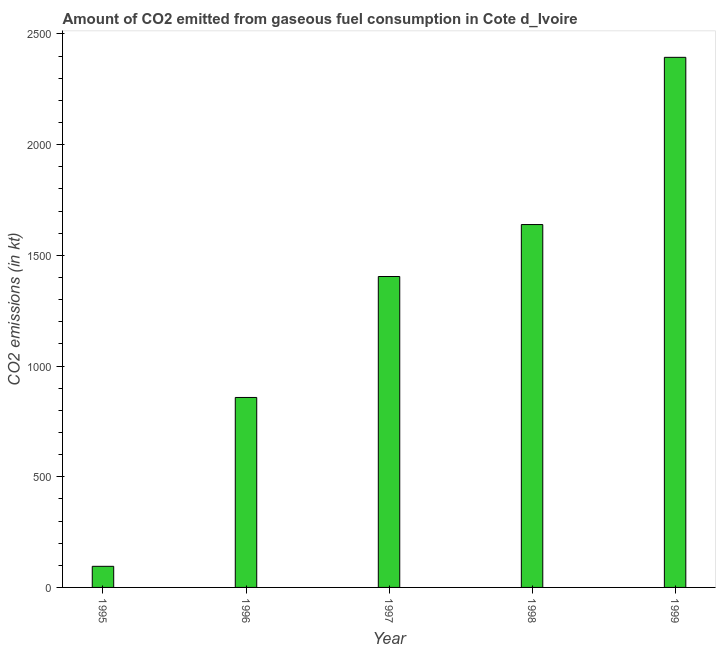Does the graph contain any zero values?
Provide a succinct answer. No. Does the graph contain grids?
Your response must be concise. No. What is the title of the graph?
Offer a very short reply. Amount of CO2 emitted from gaseous fuel consumption in Cote d_Ivoire. What is the label or title of the X-axis?
Offer a very short reply. Year. What is the label or title of the Y-axis?
Your answer should be very brief. CO2 emissions (in kt). What is the co2 emissions from gaseous fuel consumption in 1996?
Make the answer very short. 858.08. Across all years, what is the maximum co2 emissions from gaseous fuel consumption?
Your answer should be very brief. 2394.55. Across all years, what is the minimum co2 emissions from gaseous fuel consumption?
Offer a very short reply. 95.34. What is the sum of the co2 emissions from gaseous fuel consumption?
Provide a succinct answer. 6391.58. What is the difference between the co2 emissions from gaseous fuel consumption in 1998 and 1999?
Provide a succinct answer. -755.4. What is the average co2 emissions from gaseous fuel consumption per year?
Give a very brief answer. 1278.32. What is the median co2 emissions from gaseous fuel consumption?
Give a very brief answer. 1404.46. In how many years, is the co2 emissions from gaseous fuel consumption greater than 1300 kt?
Offer a very short reply. 3. What is the ratio of the co2 emissions from gaseous fuel consumption in 1995 to that in 1998?
Your response must be concise. 0.06. What is the difference between the highest and the second highest co2 emissions from gaseous fuel consumption?
Make the answer very short. 755.4. Is the sum of the co2 emissions from gaseous fuel consumption in 1995 and 1998 greater than the maximum co2 emissions from gaseous fuel consumption across all years?
Your answer should be compact. No. What is the difference between the highest and the lowest co2 emissions from gaseous fuel consumption?
Make the answer very short. 2299.21. In how many years, is the co2 emissions from gaseous fuel consumption greater than the average co2 emissions from gaseous fuel consumption taken over all years?
Give a very brief answer. 3. How many bars are there?
Make the answer very short. 5. Are all the bars in the graph horizontal?
Provide a short and direct response. No. What is the CO2 emissions (in kt) of 1995?
Your answer should be compact. 95.34. What is the CO2 emissions (in kt) of 1996?
Provide a succinct answer. 858.08. What is the CO2 emissions (in kt) of 1997?
Provide a short and direct response. 1404.46. What is the CO2 emissions (in kt) in 1998?
Offer a terse response. 1639.15. What is the CO2 emissions (in kt) in 1999?
Keep it short and to the point. 2394.55. What is the difference between the CO2 emissions (in kt) in 1995 and 1996?
Provide a succinct answer. -762.74. What is the difference between the CO2 emissions (in kt) in 1995 and 1997?
Give a very brief answer. -1309.12. What is the difference between the CO2 emissions (in kt) in 1995 and 1998?
Make the answer very short. -1543.81. What is the difference between the CO2 emissions (in kt) in 1995 and 1999?
Your response must be concise. -2299.21. What is the difference between the CO2 emissions (in kt) in 1996 and 1997?
Provide a short and direct response. -546.38. What is the difference between the CO2 emissions (in kt) in 1996 and 1998?
Your answer should be compact. -781.07. What is the difference between the CO2 emissions (in kt) in 1996 and 1999?
Offer a terse response. -1536.47. What is the difference between the CO2 emissions (in kt) in 1997 and 1998?
Provide a short and direct response. -234.69. What is the difference between the CO2 emissions (in kt) in 1997 and 1999?
Keep it short and to the point. -990.09. What is the difference between the CO2 emissions (in kt) in 1998 and 1999?
Offer a very short reply. -755.4. What is the ratio of the CO2 emissions (in kt) in 1995 to that in 1996?
Offer a very short reply. 0.11. What is the ratio of the CO2 emissions (in kt) in 1995 to that in 1997?
Provide a short and direct response. 0.07. What is the ratio of the CO2 emissions (in kt) in 1995 to that in 1998?
Keep it short and to the point. 0.06. What is the ratio of the CO2 emissions (in kt) in 1995 to that in 1999?
Offer a terse response. 0.04. What is the ratio of the CO2 emissions (in kt) in 1996 to that in 1997?
Provide a short and direct response. 0.61. What is the ratio of the CO2 emissions (in kt) in 1996 to that in 1998?
Provide a succinct answer. 0.52. What is the ratio of the CO2 emissions (in kt) in 1996 to that in 1999?
Provide a succinct answer. 0.36. What is the ratio of the CO2 emissions (in kt) in 1997 to that in 1998?
Offer a very short reply. 0.86. What is the ratio of the CO2 emissions (in kt) in 1997 to that in 1999?
Your answer should be very brief. 0.59. What is the ratio of the CO2 emissions (in kt) in 1998 to that in 1999?
Your answer should be very brief. 0.69. 